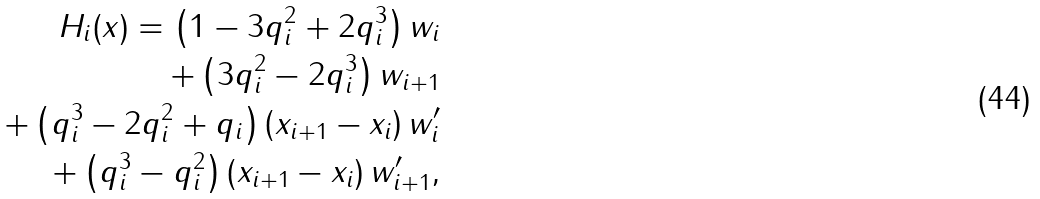<formula> <loc_0><loc_0><loc_500><loc_500>H _ { i } ( x ) = \left ( 1 - 3 q _ { i } ^ { 2 } + 2 q _ { i } ^ { 3 } \right ) w _ { i } \\ + \left ( 3 q _ { i } ^ { 2 } - 2 q _ { i } ^ { 3 } \right ) w _ { i + 1 } \\ + \left ( q _ { i } ^ { 3 } - 2 q _ { i } ^ { 2 } + q _ { i } \right ) \left ( x _ { i + 1 } - x _ { i } \right ) w ^ { \prime } _ { i } \\ + \left ( q _ { i } ^ { 3 } - q _ { i } ^ { 2 } \right ) \left ( x _ { i + 1 } - x _ { i } \right ) w ^ { \prime } _ { i + 1 } ,</formula> 